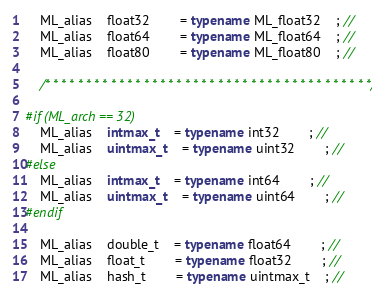Convert code to text. <code><loc_0><loc_0><loc_500><loc_500><_C++_>	ML_alias	float32		= typename ML_float32	; // 
	ML_alias	float64		= typename ML_float64	; // 
	ML_alias	float80		= typename ML_float80	; // 

	/* * * * * * * * * * * * * * * * * * * * * * * * * * * * * * * * * * * * * * * */

#if (ML_arch == 32)
	ML_alias	intmax_t	= typename int32		; // 
	ML_alias	uintmax_t	= typename uint32		; // 
#else
	ML_alias	intmax_t	= typename int64		; // 
	ML_alias	uintmax_t	= typename uint64		; // 
#endif
	
	ML_alias	double_t	= typename float64		; // 
	ML_alias	float_t		= typename float32		; // 
	ML_alias	hash_t		= typename uintmax_t	; // </code> 